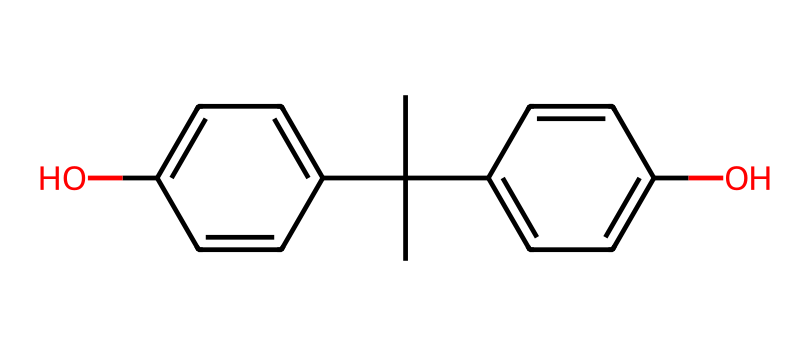What is the total number of carbon atoms in this compound? By analyzing the SMILES representation, we can identify each 'C' character, representing a carbon atom. In this structure, there are a total of 15 'C' characters counted, indicating that there are 15 carbon atoms in this compound.
Answer: 15 How many hydroxyl (–OH) groups are present in this phenol? The presence of hydroxyl groups can be deduced from the 'O' in the SMILES containing an 'H' atom (leading to –OH). In the given structure, two 'O's (from 'O') confirm that there are two hydroxyl groups.
Answer: 2 What is the degree of substitution on the aromatic rings? The aromatic rings in the structure each have hydroxyl groups attached. In this case, both rings have one substituent (–OH) each. Therefore, the degree of substitution on both rings is one.
Answer: 1 Is this compound more likely to be a solid or a liquid at room temperature? Phenolic compounds generally have solid states due to their molecular weight and structure. With the presence of multiple rings and the molecular complexity in this structure, it is more likely to be a solid at room temperature.
Answer: solid What functional groups are represented in this molecule? The primary functional group is the hydroxyl group (–OH) seen twice in the chemical structure. Phenols are characterized by the presence of these hydroxyl groups attached to their aromatic rings, making it a defining feature of this compound.
Answer: hydroxyl How do the two aromatic rings contribute to the stability of the molecule? The two aromatic rings introduce resonance, which stabilizes the molecule. Both rings can delocalize electrons, thus providing strength against disruption and improving the overall stability of the structure in various environments, including exposure to sunlight and weather elements present in outdoor artificial turf settings.
Answer: resonance 